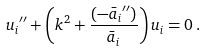Convert formula to latex. <formula><loc_0><loc_0><loc_500><loc_500>{ u _ { i } } ^ { \prime \prime } + \left ( k ^ { 2 } + \frac { ( { - \bar { a } _ { i } } ^ { \prime \prime } ) } { \bar { a } _ { i } } \right ) u _ { i } = 0 \, .</formula> 